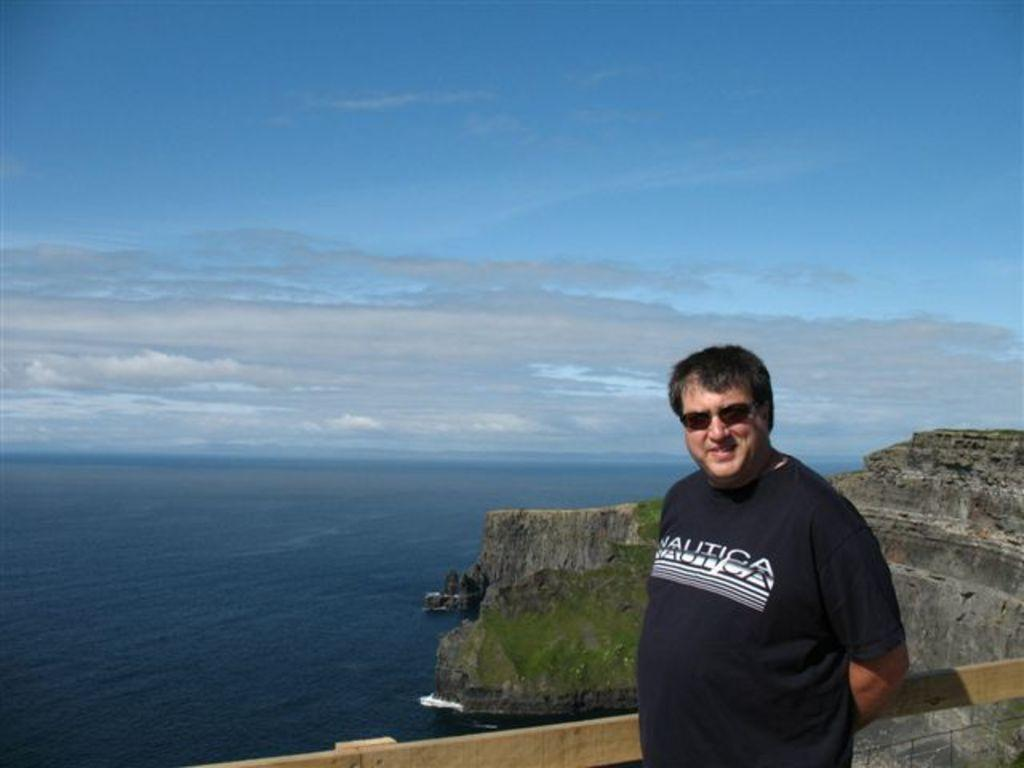What can be seen in the image? There is a person in the image, and they are wearing spectacles. What is the person doing in the image? The person is standing. What type of material is visible in the image? Wood is visible in the image. What natural features can be seen in the image? Hills, grass, and water are visible in the image. What is visible in the sky in the image? The sky is visible in the image, and clouds are present. What type of car can be seen in the image? There is no car present in the image; it features a person standing with natural elements in the background. 